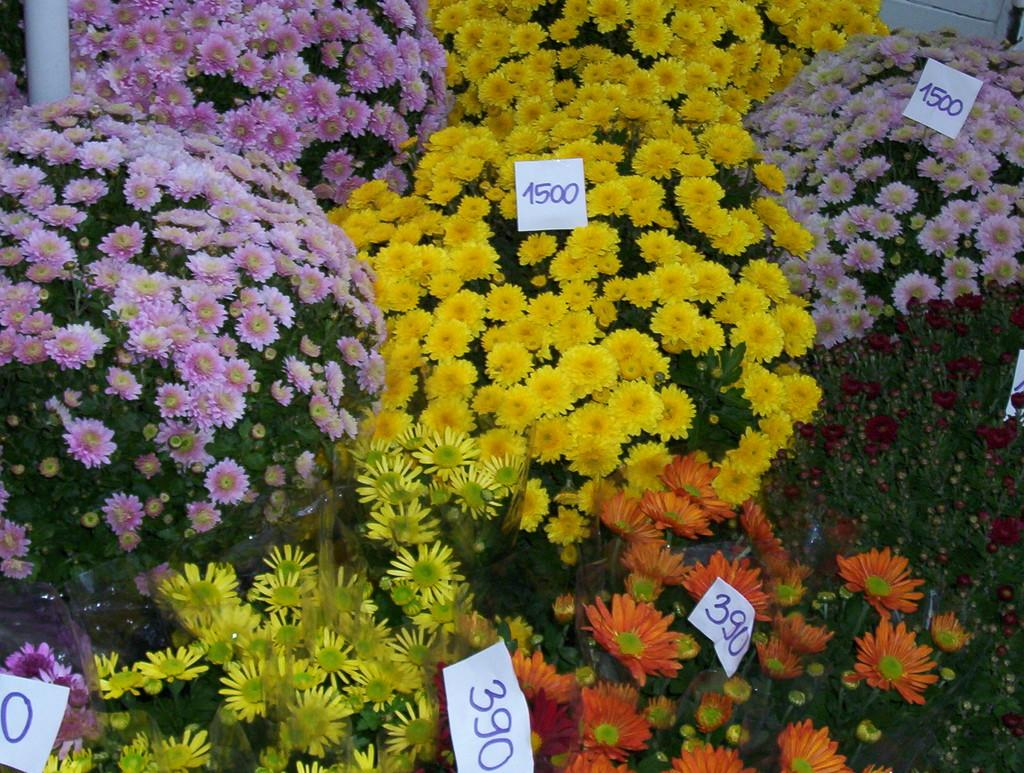What type of items are visible in the image? There are flower plants with price tags in the image. Can you describe the pole on the left side top of the image? There is a pole on the left side top of the image. What is located on the right side top of the image? There is an object on the right side top of the image. What is the income of the flower plants in the image? The income of the flower plants cannot be determined from the image, as it only shows the plants with price tags. 